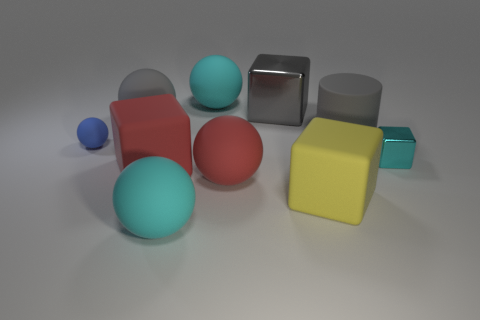Subtract all cyan spheres. How many were subtracted if there are1cyan spheres left? 1 Subtract all red balls. How many balls are left? 4 Subtract all red rubber blocks. How many blocks are left? 3 Subtract all purple blocks. Subtract all blue balls. How many blocks are left? 4 Subtract 0 yellow balls. How many objects are left? 10 Subtract all cylinders. How many objects are left? 9 Subtract all cyan things. Subtract all cyan cubes. How many objects are left? 6 Add 8 big yellow blocks. How many big yellow blocks are left? 9 Add 9 small gray cylinders. How many small gray cylinders exist? 9 